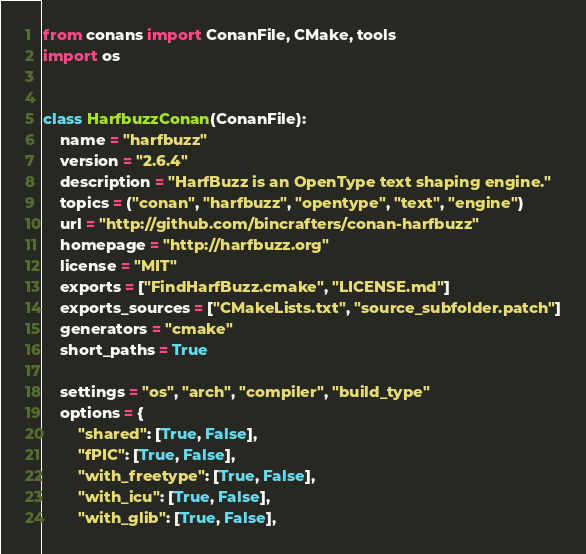<code> <loc_0><loc_0><loc_500><loc_500><_Python_>from conans import ConanFile, CMake, tools
import os


class HarfbuzzConan(ConanFile):
    name = "harfbuzz"
    version = "2.6.4"
    description = "HarfBuzz is an OpenType text shaping engine."
    topics = ("conan", "harfbuzz", "opentype", "text", "engine")
    url = "http://github.com/bincrafters/conan-harfbuzz"
    homepage = "http://harfbuzz.org"
    license = "MIT"
    exports = ["FindHarfBuzz.cmake", "LICENSE.md"]
    exports_sources = ["CMakeLists.txt", "source_subfolder.patch"]
    generators = "cmake"
    short_paths = True

    settings = "os", "arch", "compiler", "build_type"
    options = {
        "shared": [True, False],
        "fPIC": [True, False],
        "with_freetype": [True, False],
        "with_icu": [True, False],
        "with_glib": [True, False],</code> 